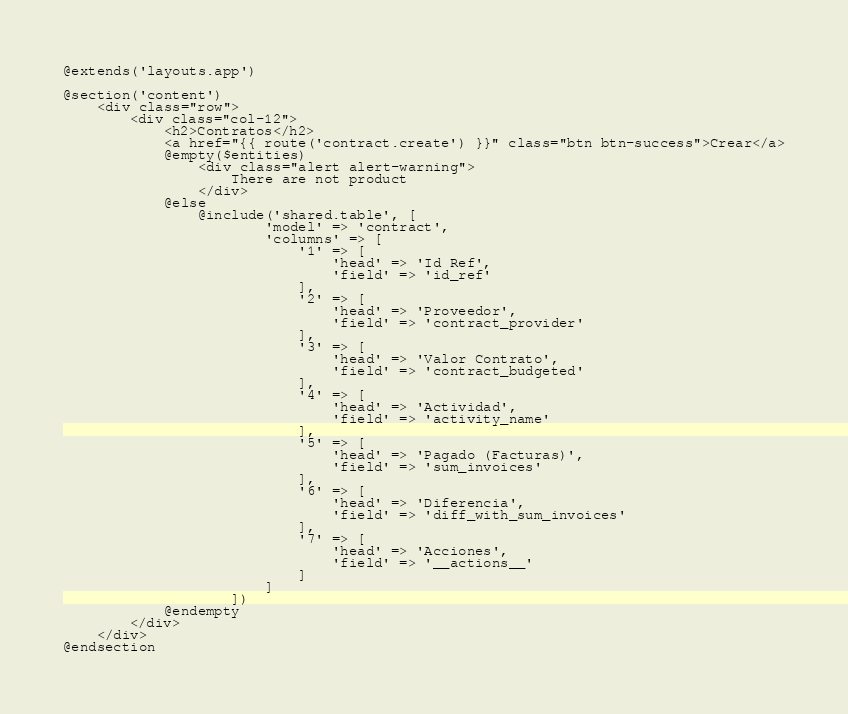Convert code to text. <code><loc_0><loc_0><loc_500><loc_500><_PHP_>@extends('layouts.app')

@section('content')
    <div class="row">
        <div class="col-12">
            <h2>Contratos</h2>
            <a href="{{ route('contract.create') }}" class="btn btn-success">Crear</a>
            @empty($entities)
                <div class="alert alert-warning">
                    There are not product
                </div>
            @else
                @include('shared.table', [
                        'model' => 'contract',
                        'columns' => [
                            '1' => [
                                'head' => 'Id Ref',
                                'field' => 'id_ref'
                            ],
                            '2' => [
                                'head' => 'Proveedor',
                                'field' => 'contract_provider'
                            ],
                            '3' => [
                                'head' => 'Valor Contrato',
                                'field' => 'contract_budgeted'
                            ],
                            '4' => [
                                'head' => 'Actividad',
                                'field' => 'activity_name'
                            ],
                            '5' => [
                                'head' => 'Pagado (Facturas)',
                                'field' => 'sum_invoices'
                            ],
                            '6' => [
                                'head' => 'Diferencia',
                                'field' => 'diff_with_sum_invoices'
                            ],
                            '7' => [
                                'head' => 'Acciones',
                                'field' => '__actions__'
                            ]
                        ]
                    ])
            @endempty
        </div>
    </div>
@endsection



</code> 